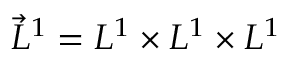<formula> <loc_0><loc_0><loc_500><loc_500>\vec { L } ^ { 1 } = L ^ { 1 } \times L ^ { 1 } \times L ^ { 1 }</formula> 